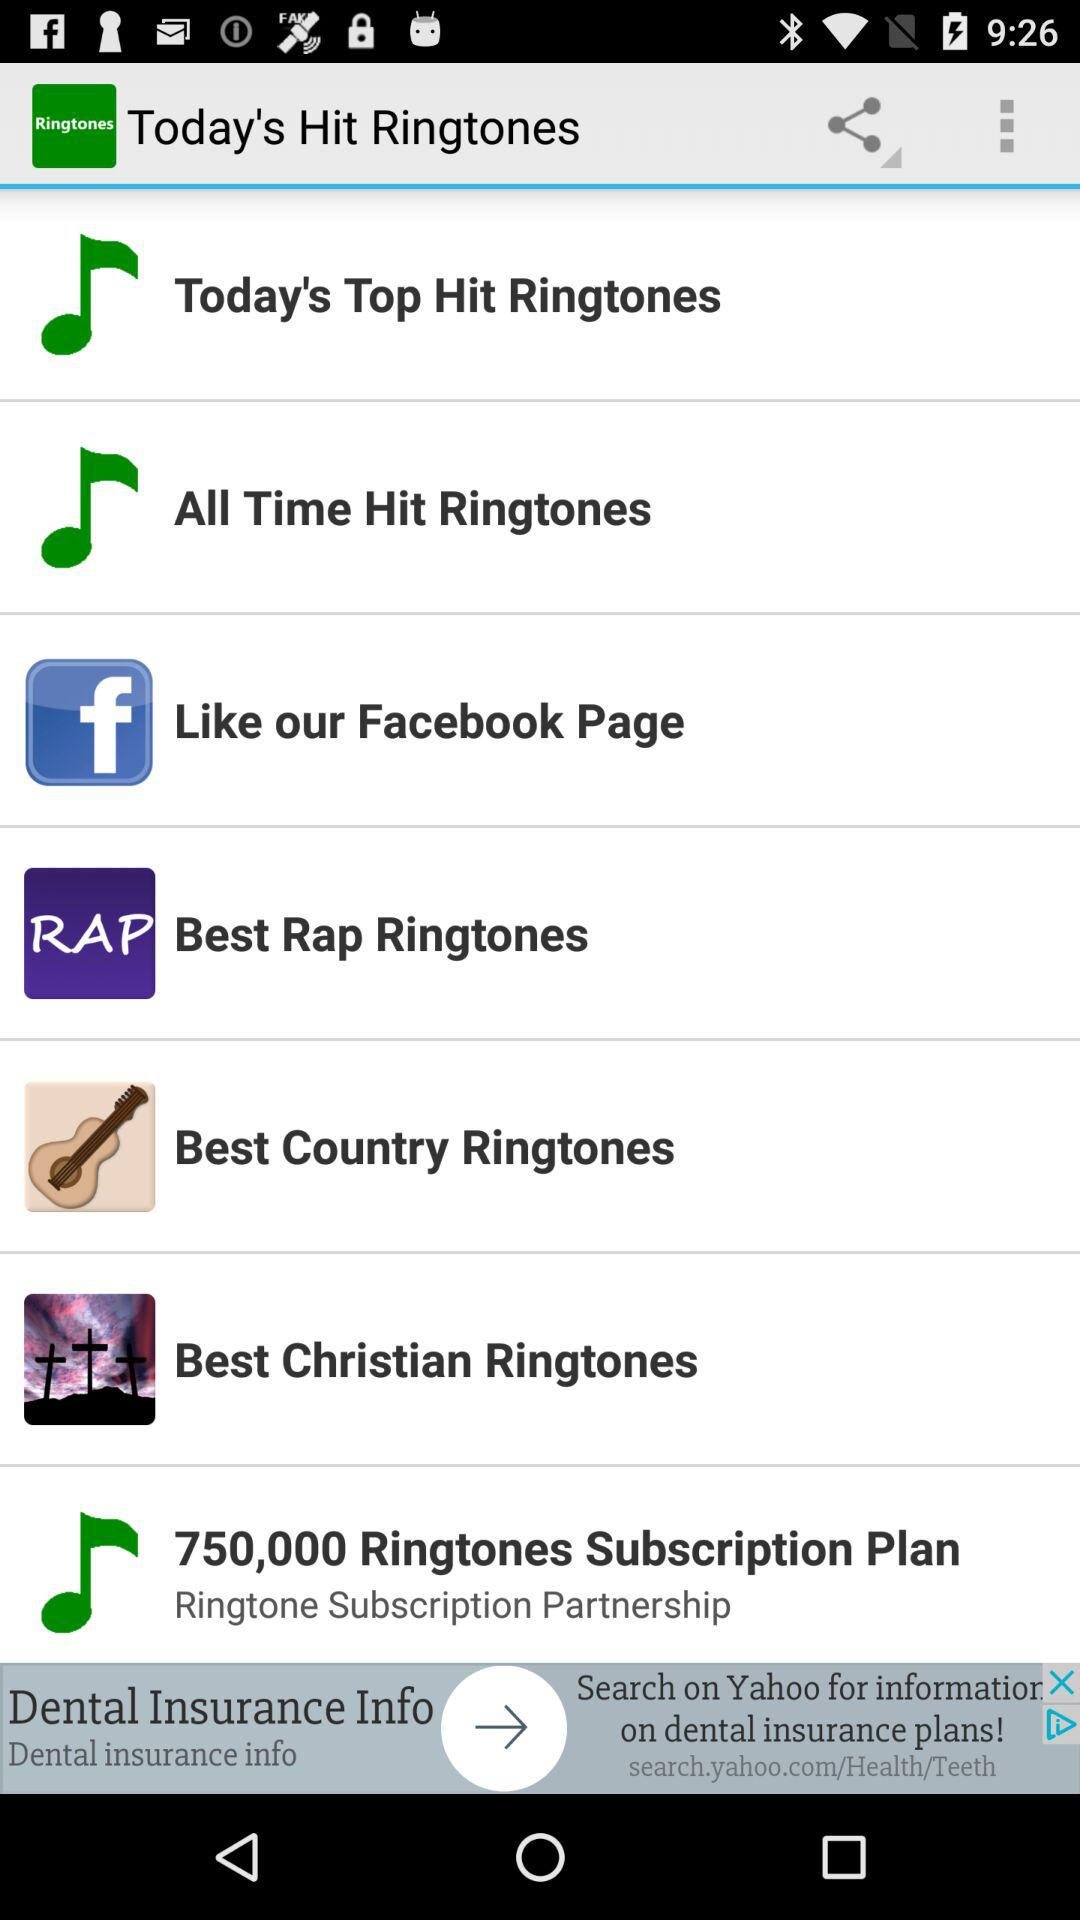What is the number of ringtones in the subscription plan? The number of ringtones in the subscription plan is 750,000. 